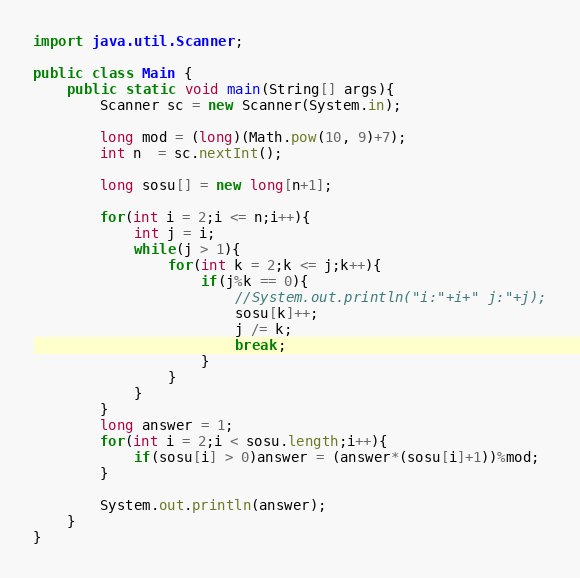<code> <loc_0><loc_0><loc_500><loc_500><_Java_>import java.util.Scanner;
 
public class Main {
	public static void main(String[] args){
		Scanner sc = new Scanner(System.in);
 
		long mod = (long)(Math.pow(10, 9)+7);
		int n  = sc.nextInt();
 
		long sosu[] = new long[n+1];
 
		for(int i = 2;i <= n;i++){
			int j = i;
			while(j > 1){
				for(int k = 2;k <= j;k++){
					if(j%k == 0){
						//System.out.println("i:"+i+" j:"+j);
						sosu[k]++;
						j /= k;
						break;
					}
				}
			}
		}
		long answer = 1;
		for(int i = 2;i < sosu.length;i++){
			if(sosu[i] > 0)answer = (answer*(sosu[i]+1))%mod;
		}
 
		System.out.println(answer);
	}
}</code> 